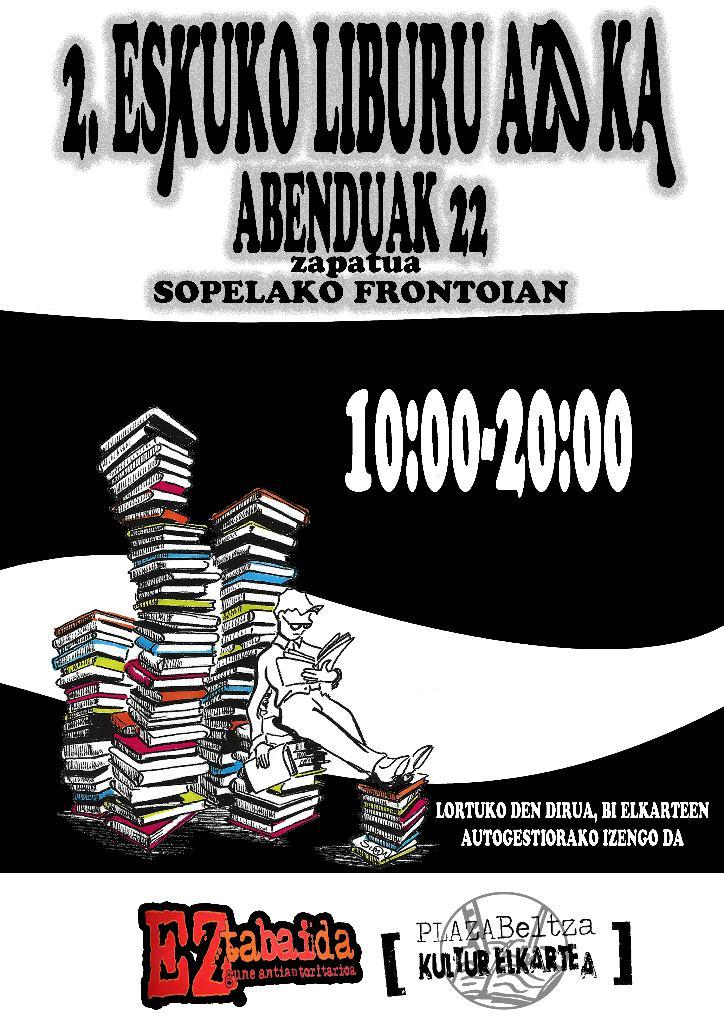<image>
Describe the image concisely. poster for eskuno liburu azoka  taking place from 10:00-20:00 